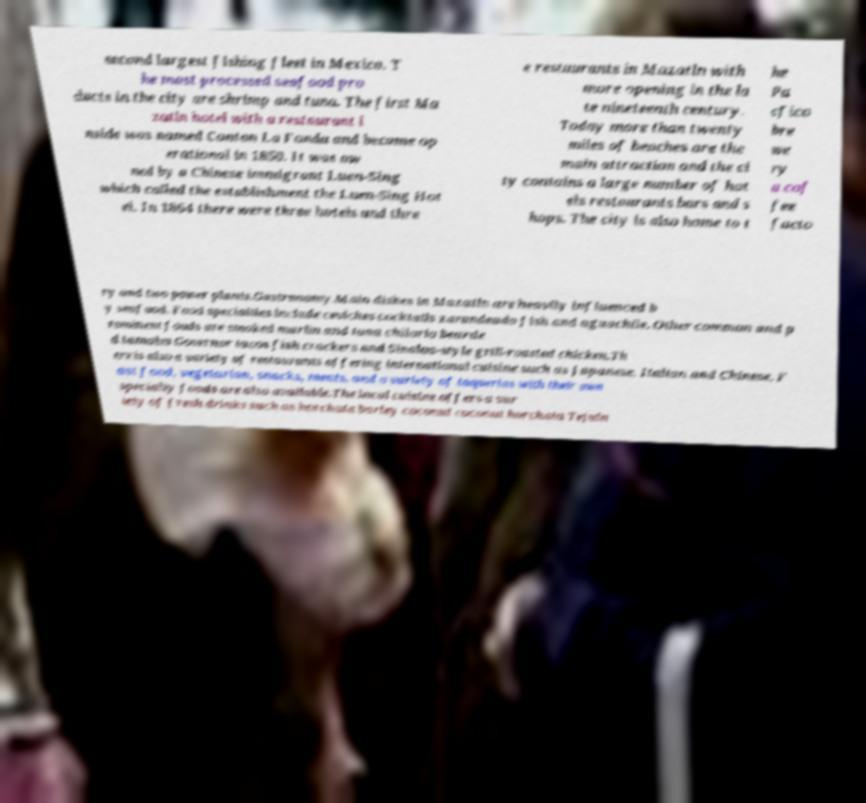Please read and relay the text visible in this image. What does it say? second largest fishing fleet in Mexico. T he most processed seafood pro ducts in the city are shrimp and tuna. The first Ma zatln hotel with a restaurant i nside was named Canton La Fonda and became op erational in 1850. It was ow ned by a Chinese immigrant Luen-Sing which called the establishment the Luen-Sing Hot el. In 1864 there were three hotels and thre e restaurants in Mazatln with more opening in the la te nineteenth century. Today more than twenty miles of beaches are the main attraction and the ci ty contains a large number of hot els restaurants bars and s hops. The city is also home to t he Pa cfico bre we ry a cof fee facto ry and two power plants.Gastronomy.Main dishes in Mazatln are heavily influenced b y seafood. Food specialties include ceviches cocktails zarandeado fish and aguachile. Other common and p rominent foods are smoked marlin and tuna chilorio bearde d tamales Governor tacos fish crackers and Sinaloa-style grill-roasted chicken.Th ere is also a variety of restaurants offering international cuisine such as Japanese, Italian and Chinese. F ast food, vegetarian, snacks, meats, and a variety of taquerias with their own specialty foods are also available.The local cuisine offers a var iety of fresh drinks such as horchata barley coconut coconut horchata Tejuin 